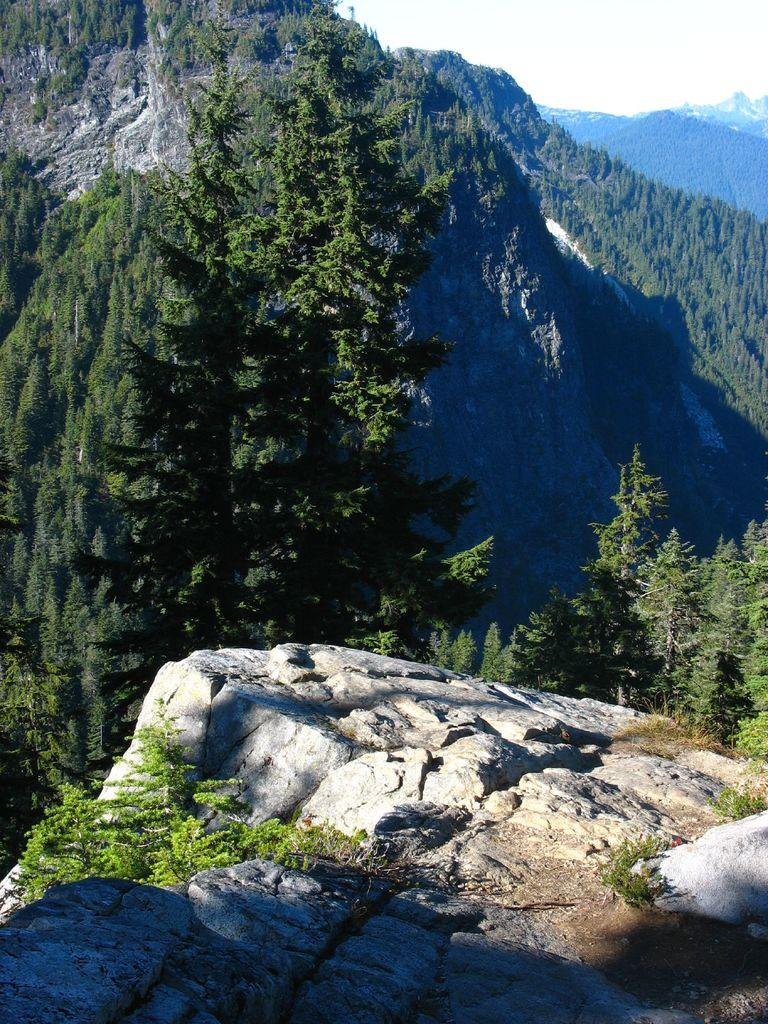What type of vegetation can be seen on the mountains in the image? There are trees on the mountains in the image. What is the color of the sky in the image? The sky is white in color. What type of wool can be seen on the trees in the image? There is no wool present on the trees in the image; they are covered with leaves or needles, depending on the type of tree. What color are the crayons used to draw the image? The facts provided do not mention any crayons or drawing materials, so it is impossible to determine the color of the crayons used. 